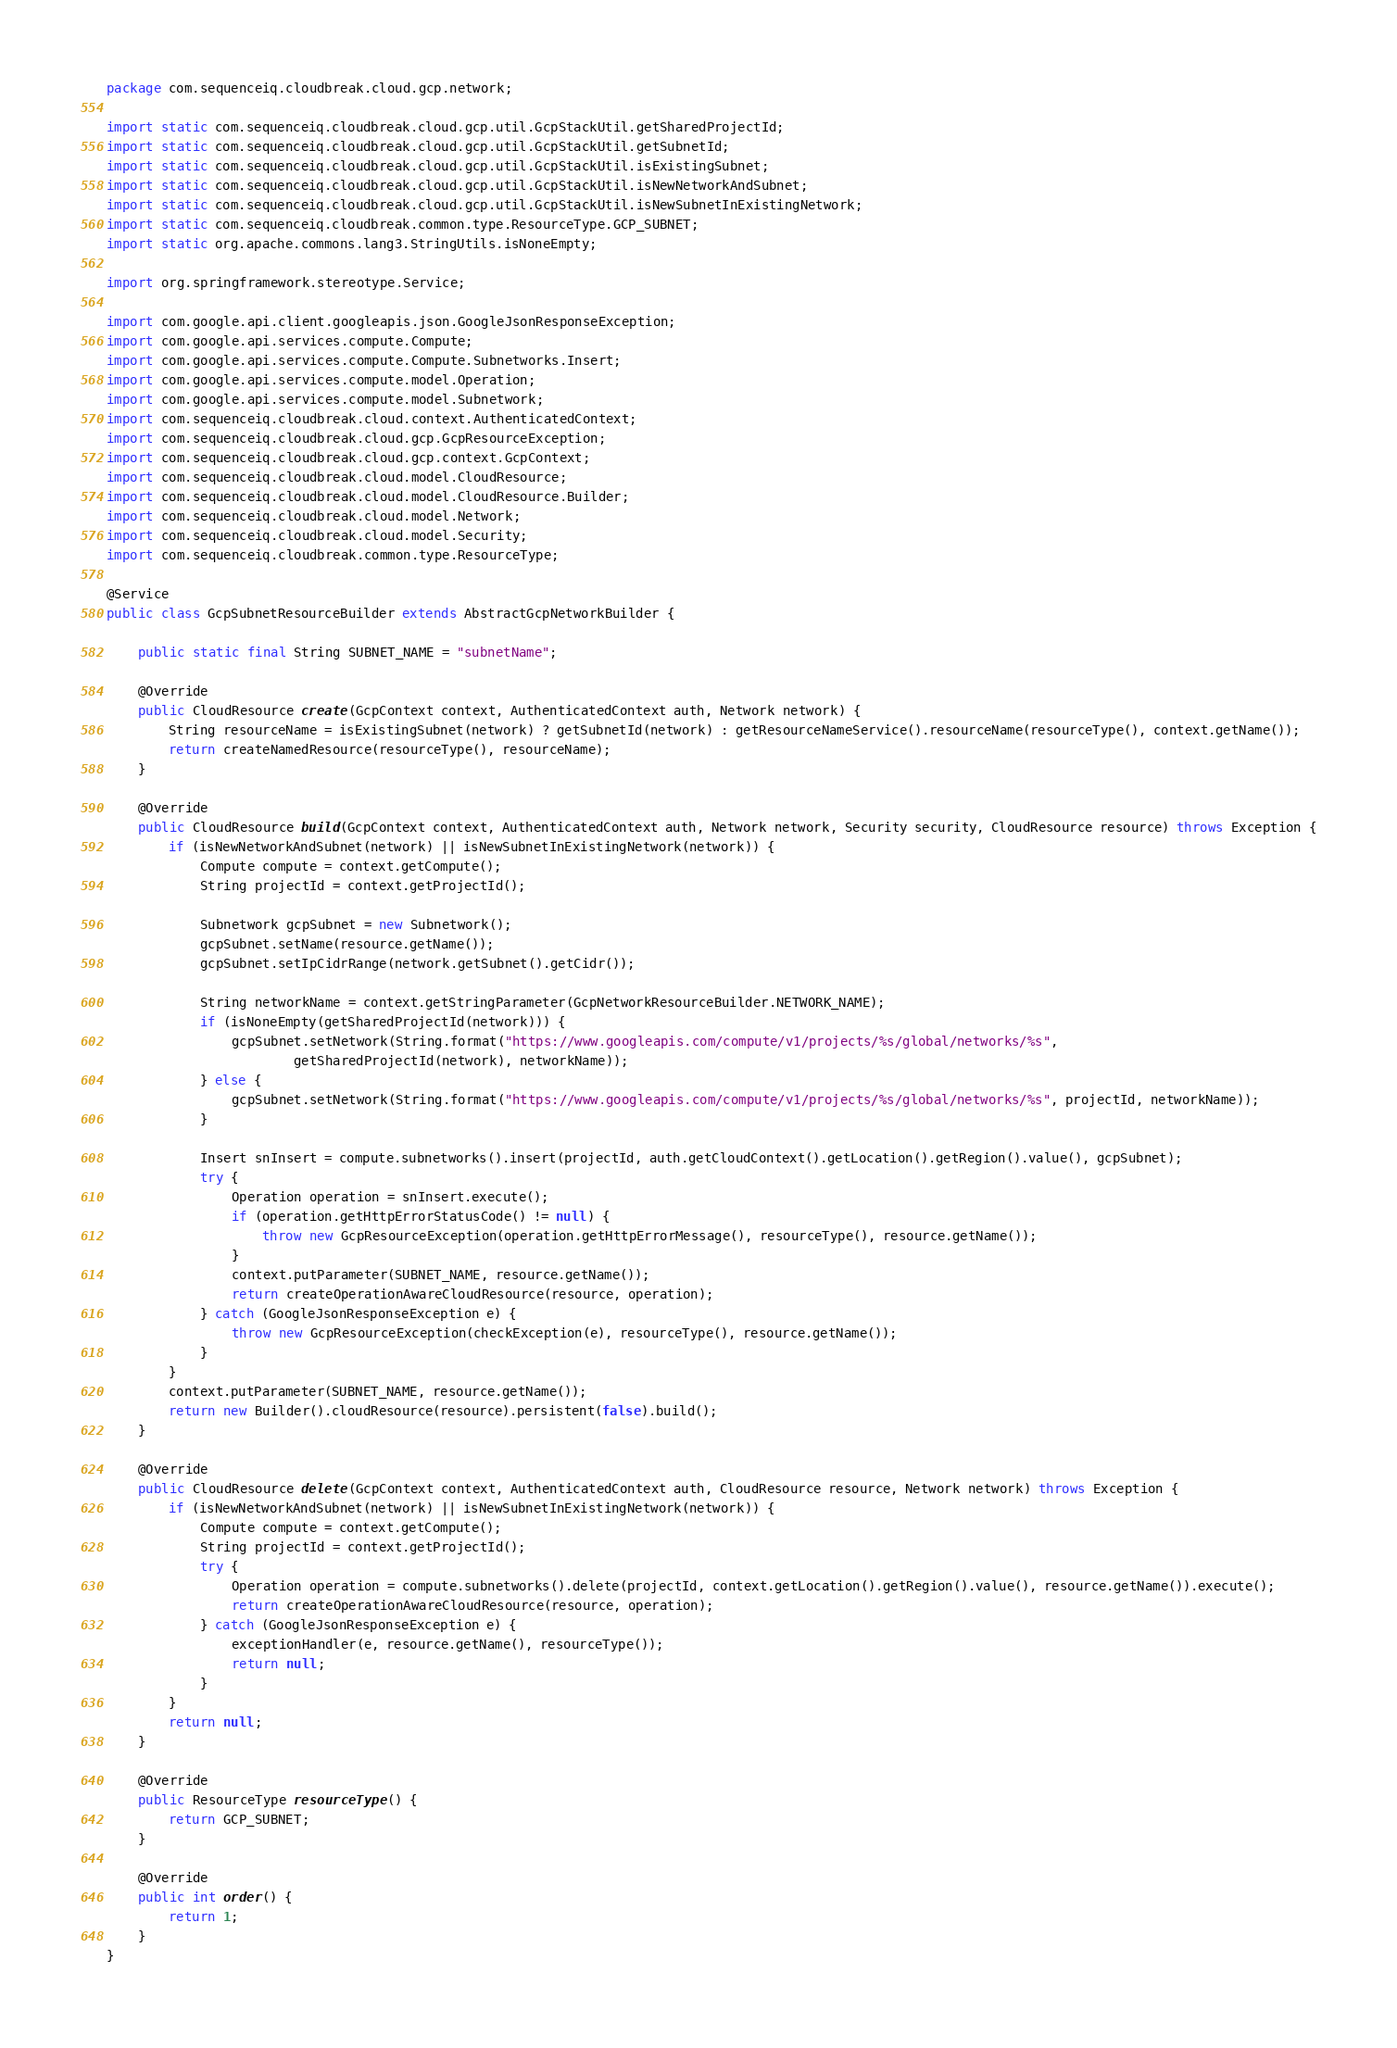Convert code to text. <code><loc_0><loc_0><loc_500><loc_500><_Java_>package com.sequenceiq.cloudbreak.cloud.gcp.network;

import static com.sequenceiq.cloudbreak.cloud.gcp.util.GcpStackUtil.getSharedProjectId;
import static com.sequenceiq.cloudbreak.cloud.gcp.util.GcpStackUtil.getSubnetId;
import static com.sequenceiq.cloudbreak.cloud.gcp.util.GcpStackUtil.isExistingSubnet;
import static com.sequenceiq.cloudbreak.cloud.gcp.util.GcpStackUtil.isNewNetworkAndSubnet;
import static com.sequenceiq.cloudbreak.cloud.gcp.util.GcpStackUtil.isNewSubnetInExistingNetwork;
import static com.sequenceiq.cloudbreak.common.type.ResourceType.GCP_SUBNET;
import static org.apache.commons.lang3.StringUtils.isNoneEmpty;

import org.springframework.stereotype.Service;

import com.google.api.client.googleapis.json.GoogleJsonResponseException;
import com.google.api.services.compute.Compute;
import com.google.api.services.compute.Compute.Subnetworks.Insert;
import com.google.api.services.compute.model.Operation;
import com.google.api.services.compute.model.Subnetwork;
import com.sequenceiq.cloudbreak.cloud.context.AuthenticatedContext;
import com.sequenceiq.cloudbreak.cloud.gcp.GcpResourceException;
import com.sequenceiq.cloudbreak.cloud.gcp.context.GcpContext;
import com.sequenceiq.cloudbreak.cloud.model.CloudResource;
import com.sequenceiq.cloudbreak.cloud.model.CloudResource.Builder;
import com.sequenceiq.cloudbreak.cloud.model.Network;
import com.sequenceiq.cloudbreak.cloud.model.Security;
import com.sequenceiq.cloudbreak.common.type.ResourceType;

@Service
public class GcpSubnetResourceBuilder extends AbstractGcpNetworkBuilder {

    public static final String SUBNET_NAME = "subnetName";

    @Override
    public CloudResource create(GcpContext context, AuthenticatedContext auth, Network network) {
        String resourceName = isExistingSubnet(network) ? getSubnetId(network) : getResourceNameService().resourceName(resourceType(), context.getName());
        return createNamedResource(resourceType(), resourceName);
    }

    @Override
    public CloudResource build(GcpContext context, AuthenticatedContext auth, Network network, Security security, CloudResource resource) throws Exception {
        if (isNewNetworkAndSubnet(network) || isNewSubnetInExistingNetwork(network)) {
            Compute compute = context.getCompute();
            String projectId = context.getProjectId();

            Subnetwork gcpSubnet = new Subnetwork();
            gcpSubnet.setName(resource.getName());
            gcpSubnet.setIpCidrRange(network.getSubnet().getCidr());

            String networkName = context.getStringParameter(GcpNetworkResourceBuilder.NETWORK_NAME);
            if (isNoneEmpty(getSharedProjectId(network))) {
                gcpSubnet.setNetwork(String.format("https://www.googleapis.com/compute/v1/projects/%s/global/networks/%s",
                        getSharedProjectId(network), networkName));
            } else {
                gcpSubnet.setNetwork(String.format("https://www.googleapis.com/compute/v1/projects/%s/global/networks/%s", projectId, networkName));
            }

            Insert snInsert = compute.subnetworks().insert(projectId, auth.getCloudContext().getLocation().getRegion().value(), gcpSubnet);
            try {
                Operation operation = snInsert.execute();
                if (operation.getHttpErrorStatusCode() != null) {
                    throw new GcpResourceException(operation.getHttpErrorMessage(), resourceType(), resource.getName());
                }
                context.putParameter(SUBNET_NAME, resource.getName());
                return createOperationAwareCloudResource(resource, operation);
            } catch (GoogleJsonResponseException e) {
                throw new GcpResourceException(checkException(e), resourceType(), resource.getName());
            }
        }
        context.putParameter(SUBNET_NAME, resource.getName());
        return new Builder().cloudResource(resource).persistent(false).build();
    }

    @Override
    public CloudResource delete(GcpContext context, AuthenticatedContext auth, CloudResource resource, Network network) throws Exception {
        if (isNewNetworkAndSubnet(network) || isNewSubnetInExistingNetwork(network)) {
            Compute compute = context.getCompute();
            String projectId = context.getProjectId();
            try {
                Operation operation = compute.subnetworks().delete(projectId, context.getLocation().getRegion().value(), resource.getName()).execute();
                return createOperationAwareCloudResource(resource, operation);
            } catch (GoogleJsonResponseException e) {
                exceptionHandler(e, resource.getName(), resourceType());
                return null;
            }
        }
        return null;
    }

    @Override
    public ResourceType resourceType() {
        return GCP_SUBNET;
    }

    @Override
    public int order() {
        return 1;
    }
}
</code> 